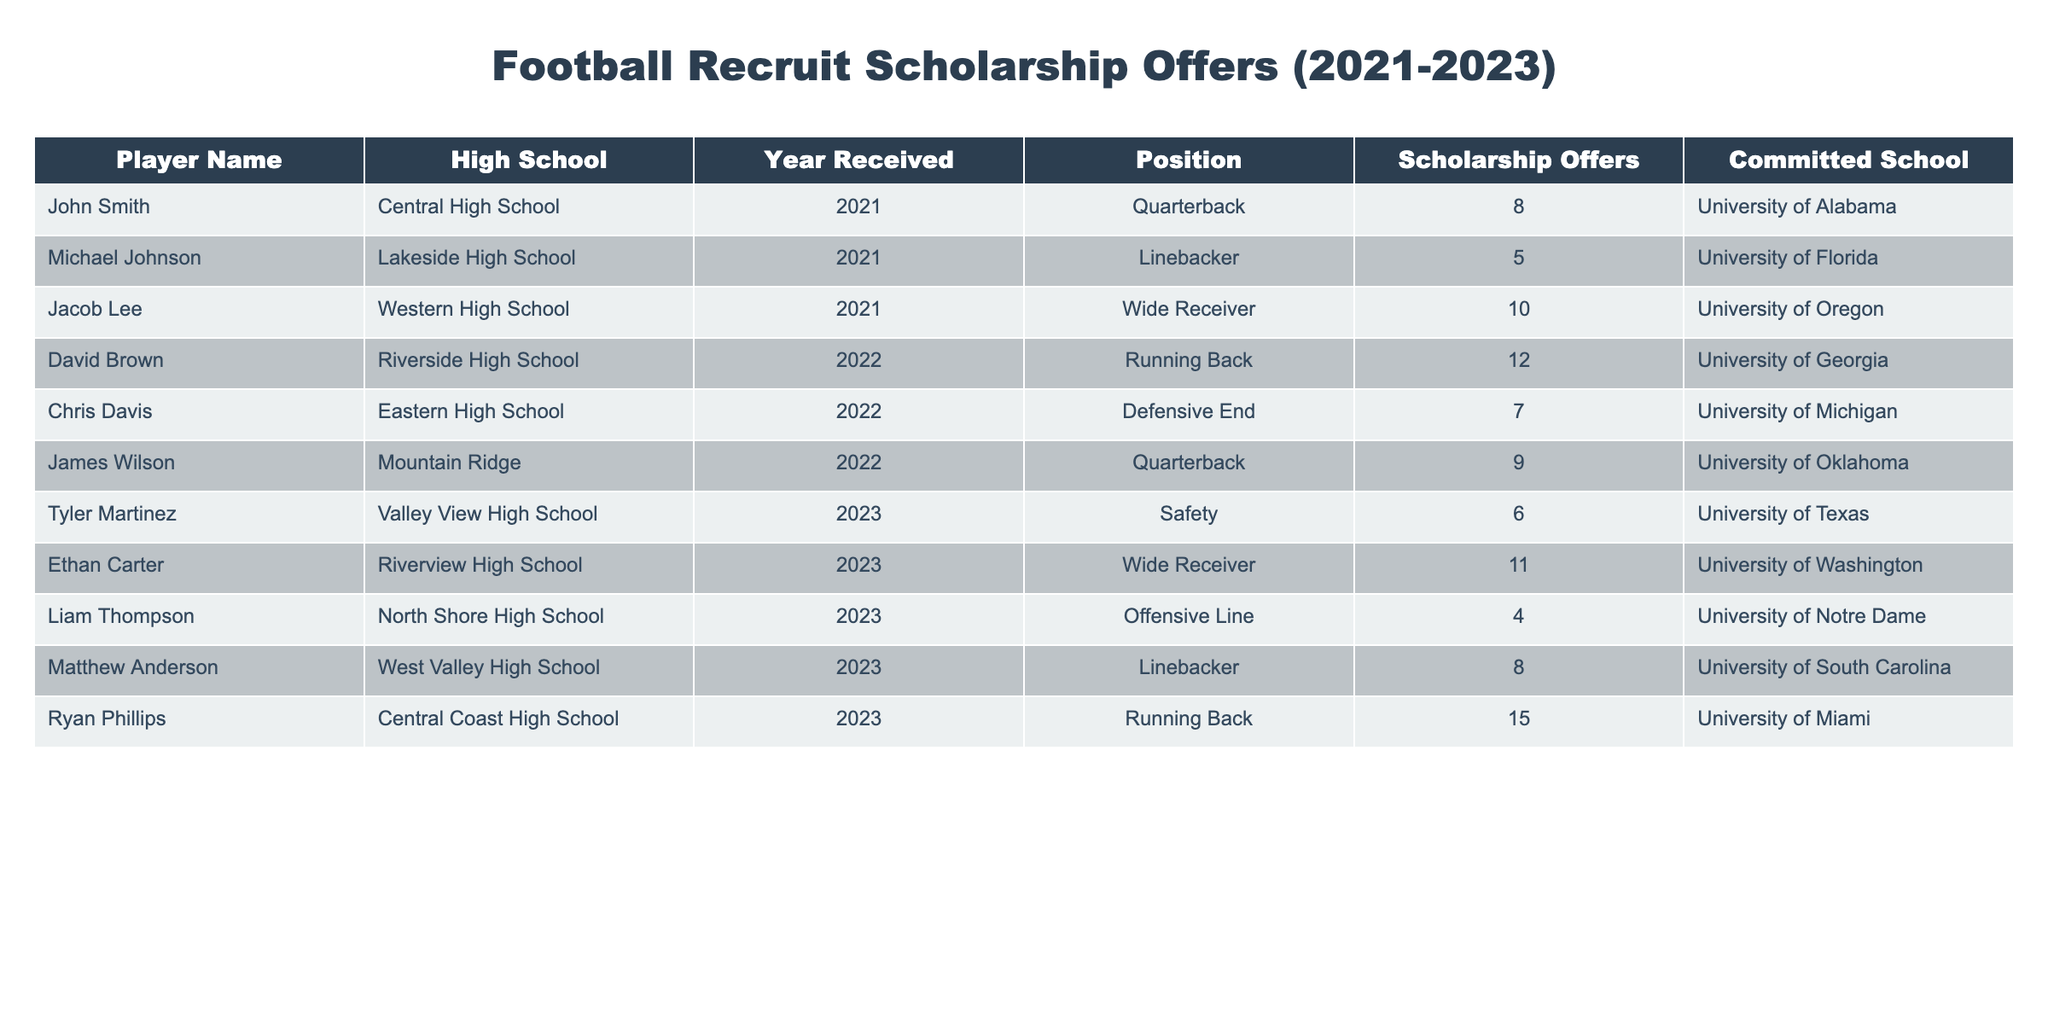What is the name of the player who received the most scholarship offers? By reviewing the "Scholarship Offers" column, Ryan Phillips has the highest number of offers listed as 15.
Answer: Ryan Phillips In which year did David Brown receive his scholarship offer? The "Year Received" column shows that David Brown's offer was received in 2022.
Answer: 2022 Which position had the least number of scholarship offers received? Comparing the "Scholarship Offers" values for each position, Liam Thompson is listed as a lineman with only 4 offers.
Answer: Offensive Line How many players committed to the University of Michigan? In the "Committed School" column, Chris Davis is the only player committed to the University of Michigan, indicating one commitment.
Answer: 1 What is the total number of scholarship offers received by players in 2023? Summing up the scholarship offers from the "Scholarship Offers" column for 2023: 6 + 11 + 4 + 8 + 15 = 44.
Answer: 44 True or False: Jacob Lee committed to University of Alabama. Reviewing the "Committed School" column, Jacob Lee is shown to have committed to the University of Oregon, not Alabama, so the statement is false.
Answer: False What is the average number of scholarship offers received by players in 2021? The offers for players in 2021 are 8, 5, and 10. Summing these gives 8 + 5 + 10 = 23; there are 3 players, so the average is 23 / 3 = 7.67.
Answer: 7.67 How many more offers did Ryan Phillips receive compared to the player with the second-highest offers? Ryan Phillips has 15 offers, and the second-highest is David Brown with 12 offers. The difference is 15 - 12 = 3.
Answer: 3 Which high school had a player that received exactly 8 scholarship offers? The "High School" column indicates that both John Smith from Central High School and Matthew Anderson from West Valley High School received 8 offers, meaning there are two high schools that match.
Answer: 2 High Schools Which position had the highest total number of scholarship offers? The total offers by position are: Quarterback (8 + 9 = 17), Linebacker (5 + 8 = 13), Wide Receiver (10 + 11 = 21), Running Back (12 + 15 = 27), Defensive End (7), Offensive Line (4), and Safety (6). The highest is Running Back with 27.
Answer: Running Back 